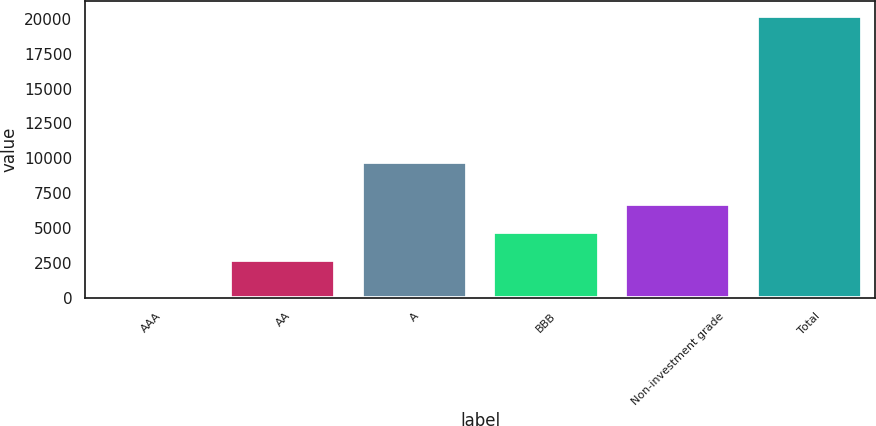<chart> <loc_0><loc_0><loc_500><loc_500><bar_chart><fcel>AAA<fcel>AA<fcel>A<fcel>BBB<fcel>Non-investment grade<fcel>Total<nl><fcel>203<fcel>2689<fcel>9748<fcel>4692.3<fcel>6695.6<fcel>20236<nl></chart> 